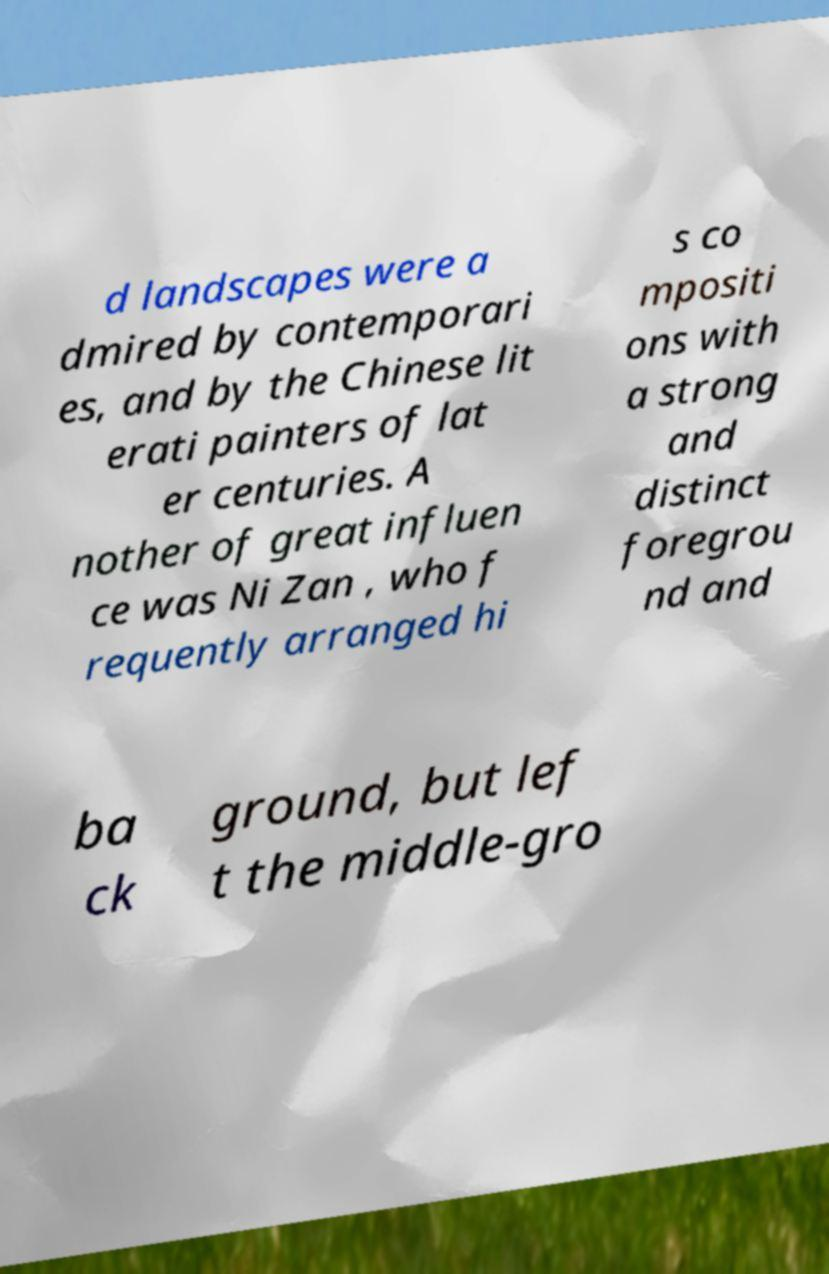There's text embedded in this image that I need extracted. Can you transcribe it verbatim? d landscapes were a dmired by contemporari es, and by the Chinese lit erati painters of lat er centuries. A nother of great influen ce was Ni Zan , who f requently arranged hi s co mpositi ons with a strong and distinct foregrou nd and ba ck ground, but lef t the middle-gro 